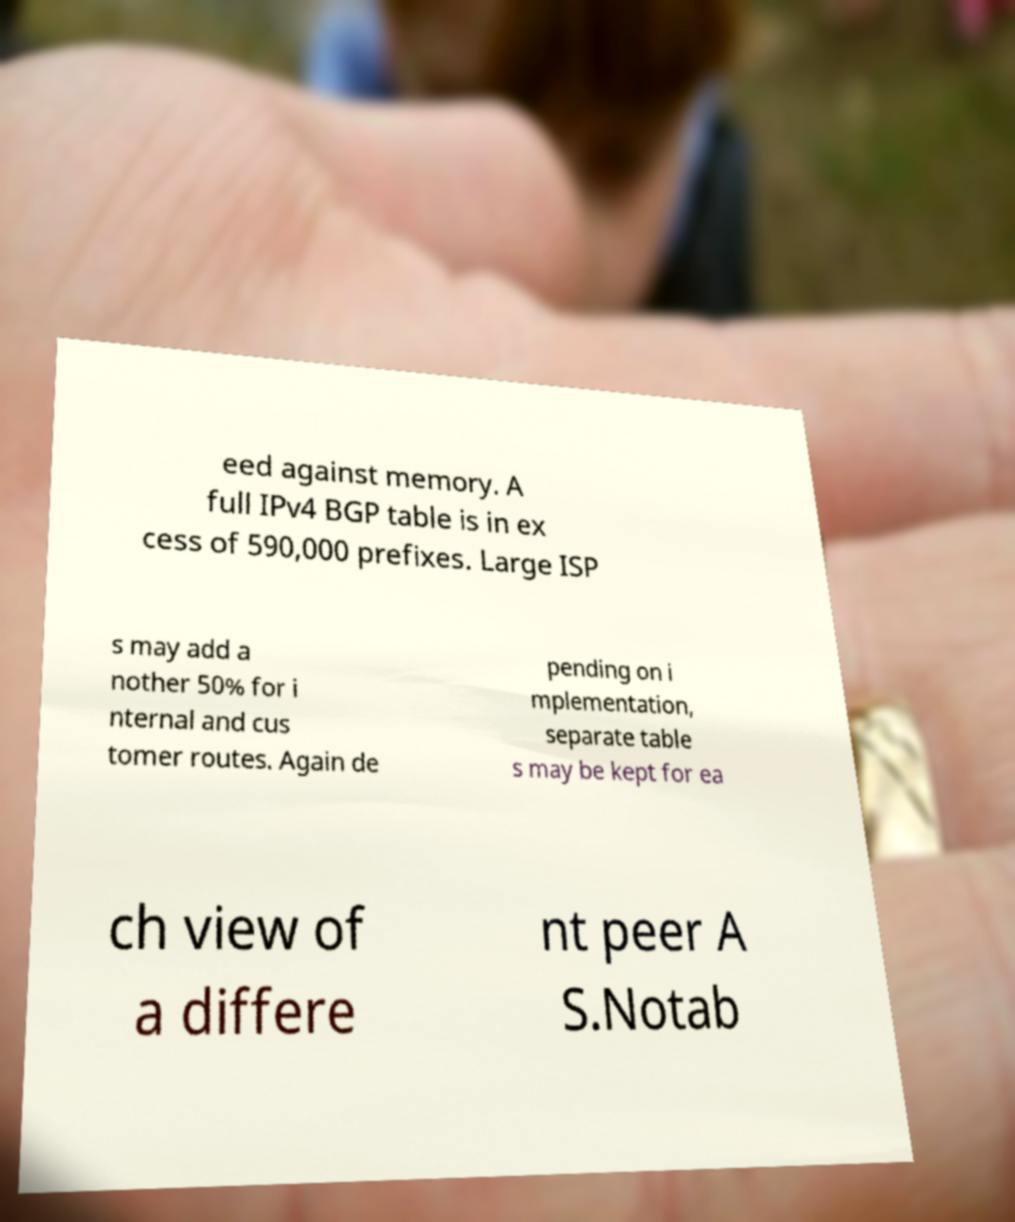Please read and relay the text visible in this image. What does it say? eed against memory. A full IPv4 BGP table is in ex cess of 590,000 prefixes. Large ISP s may add a nother 50% for i nternal and cus tomer routes. Again de pending on i mplementation, separate table s may be kept for ea ch view of a differe nt peer A S.Notab 